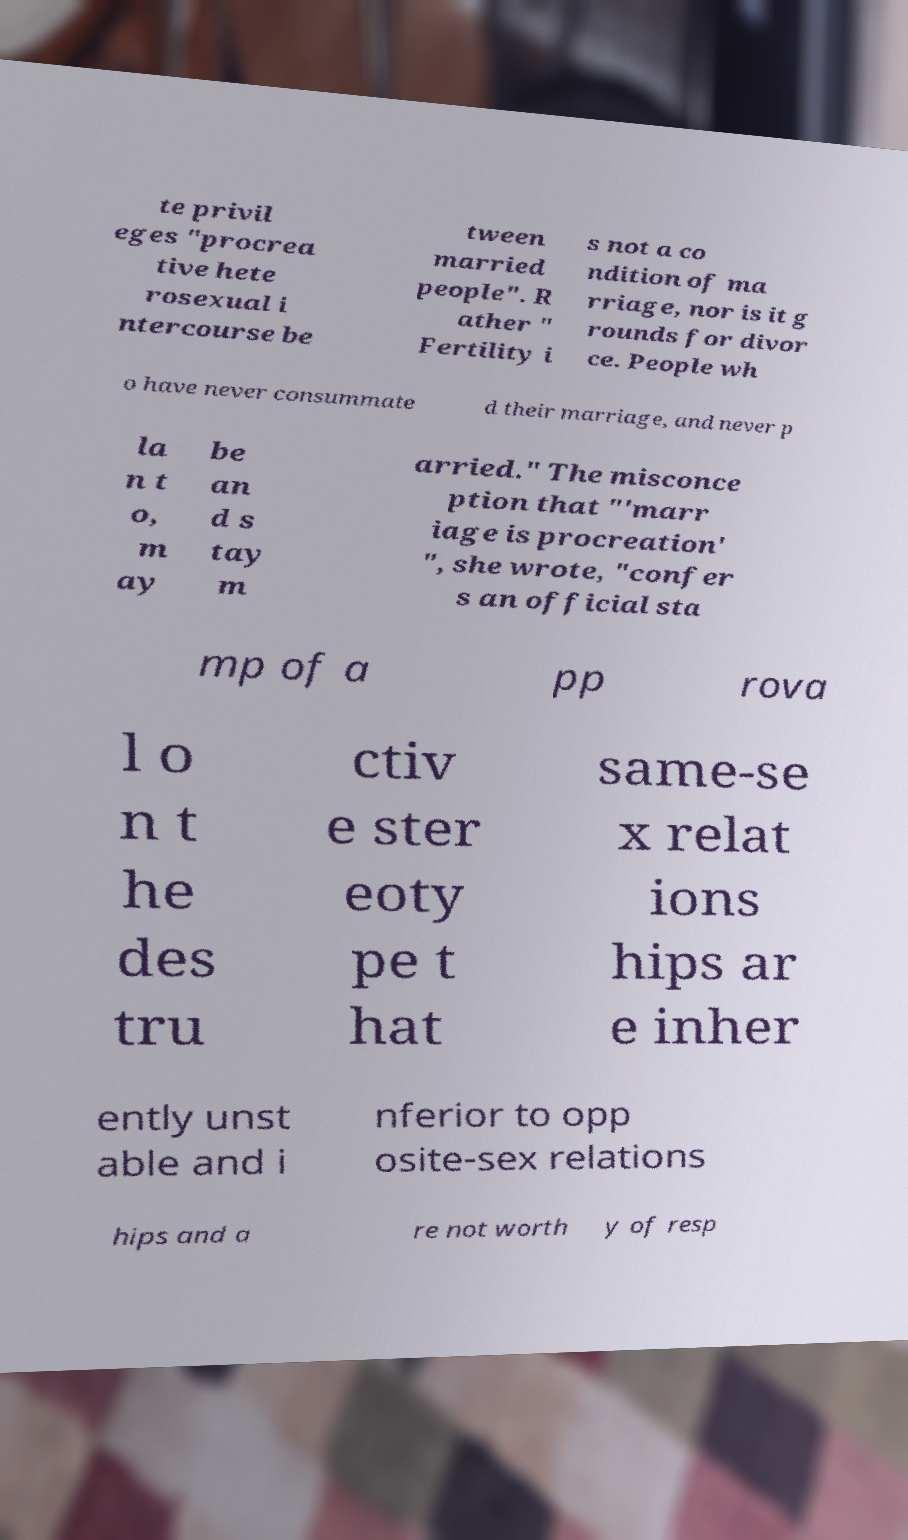For documentation purposes, I need the text within this image transcribed. Could you provide that? te privil eges "procrea tive hete rosexual i ntercourse be tween married people". R ather " Fertility i s not a co ndition of ma rriage, nor is it g rounds for divor ce. People wh o have never consummate d their marriage, and never p la n t o, m ay be an d s tay m arried." The misconce ption that "'marr iage is procreation' ", she wrote, "confer s an official sta mp of a pp rova l o n t he des tru ctiv e ster eoty pe t hat same-se x relat ions hips ar e inher ently unst able and i nferior to opp osite-sex relations hips and a re not worth y of resp 